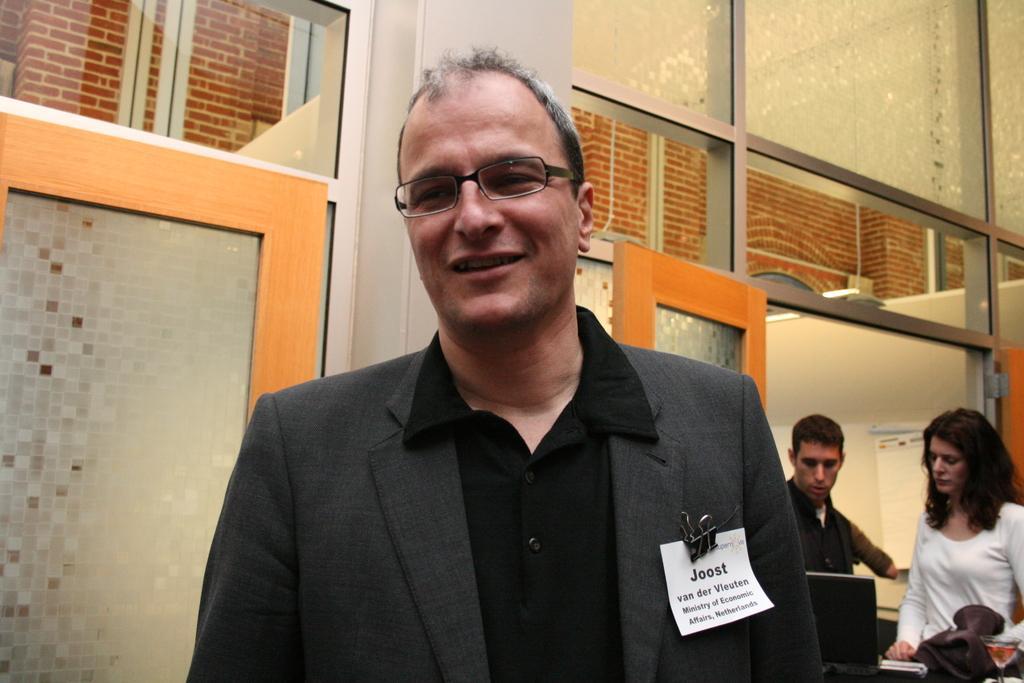How would you summarize this image in a sentence or two? In this image in front there is a person wearing a smile on his face. Behind him there are two other people standing in front of the laptop. In the background of the image there is a door. There are glass windows. There is a wall with the poster on it. 